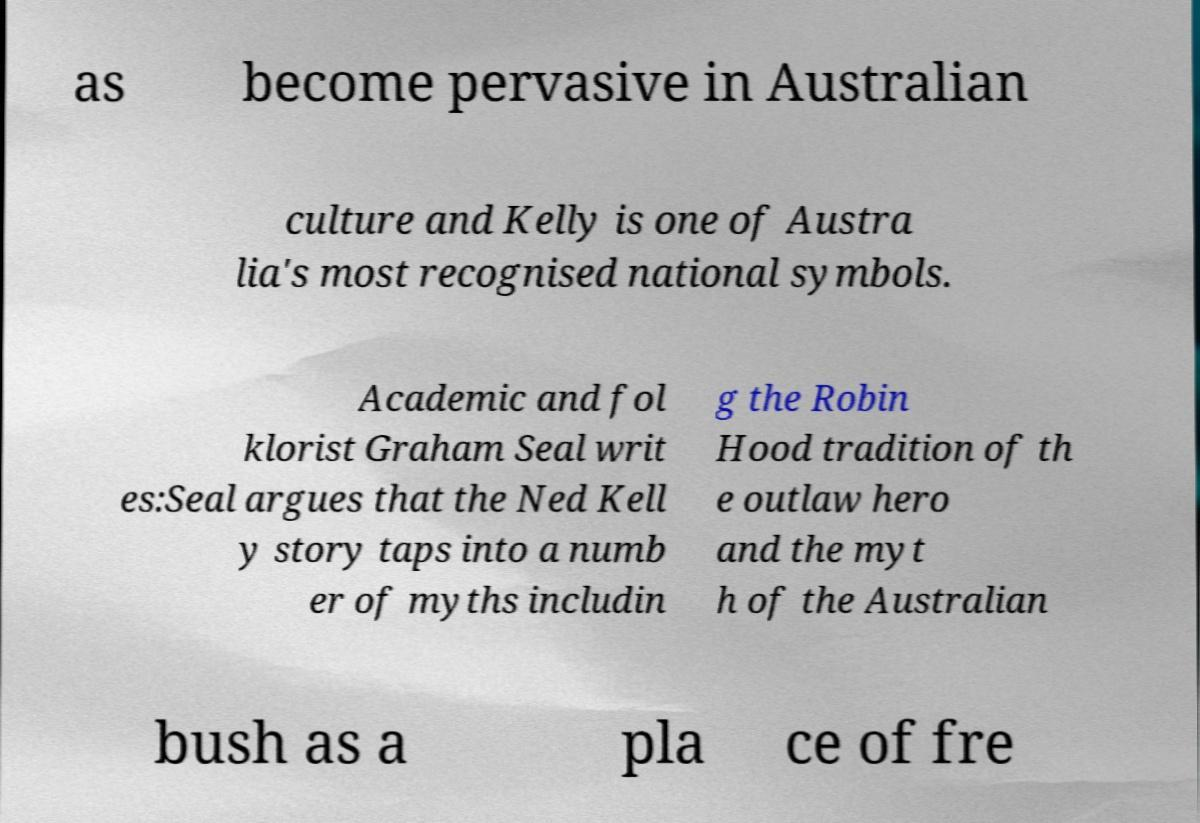Can you read and provide the text displayed in the image?This photo seems to have some interesting text. Can you extract and type it out for me? as become pervasive in Australian culture and Kelly is one of Austra lia's most recognised national symbols. Academic and fol klorist Graham Seal writ es:Seal argues that the Ned Kell y story taps into a numb er of myths includin g the Robin Hood tradition of th e outlaw hero and the myt h of the Australian bush as a pla ce of fre 